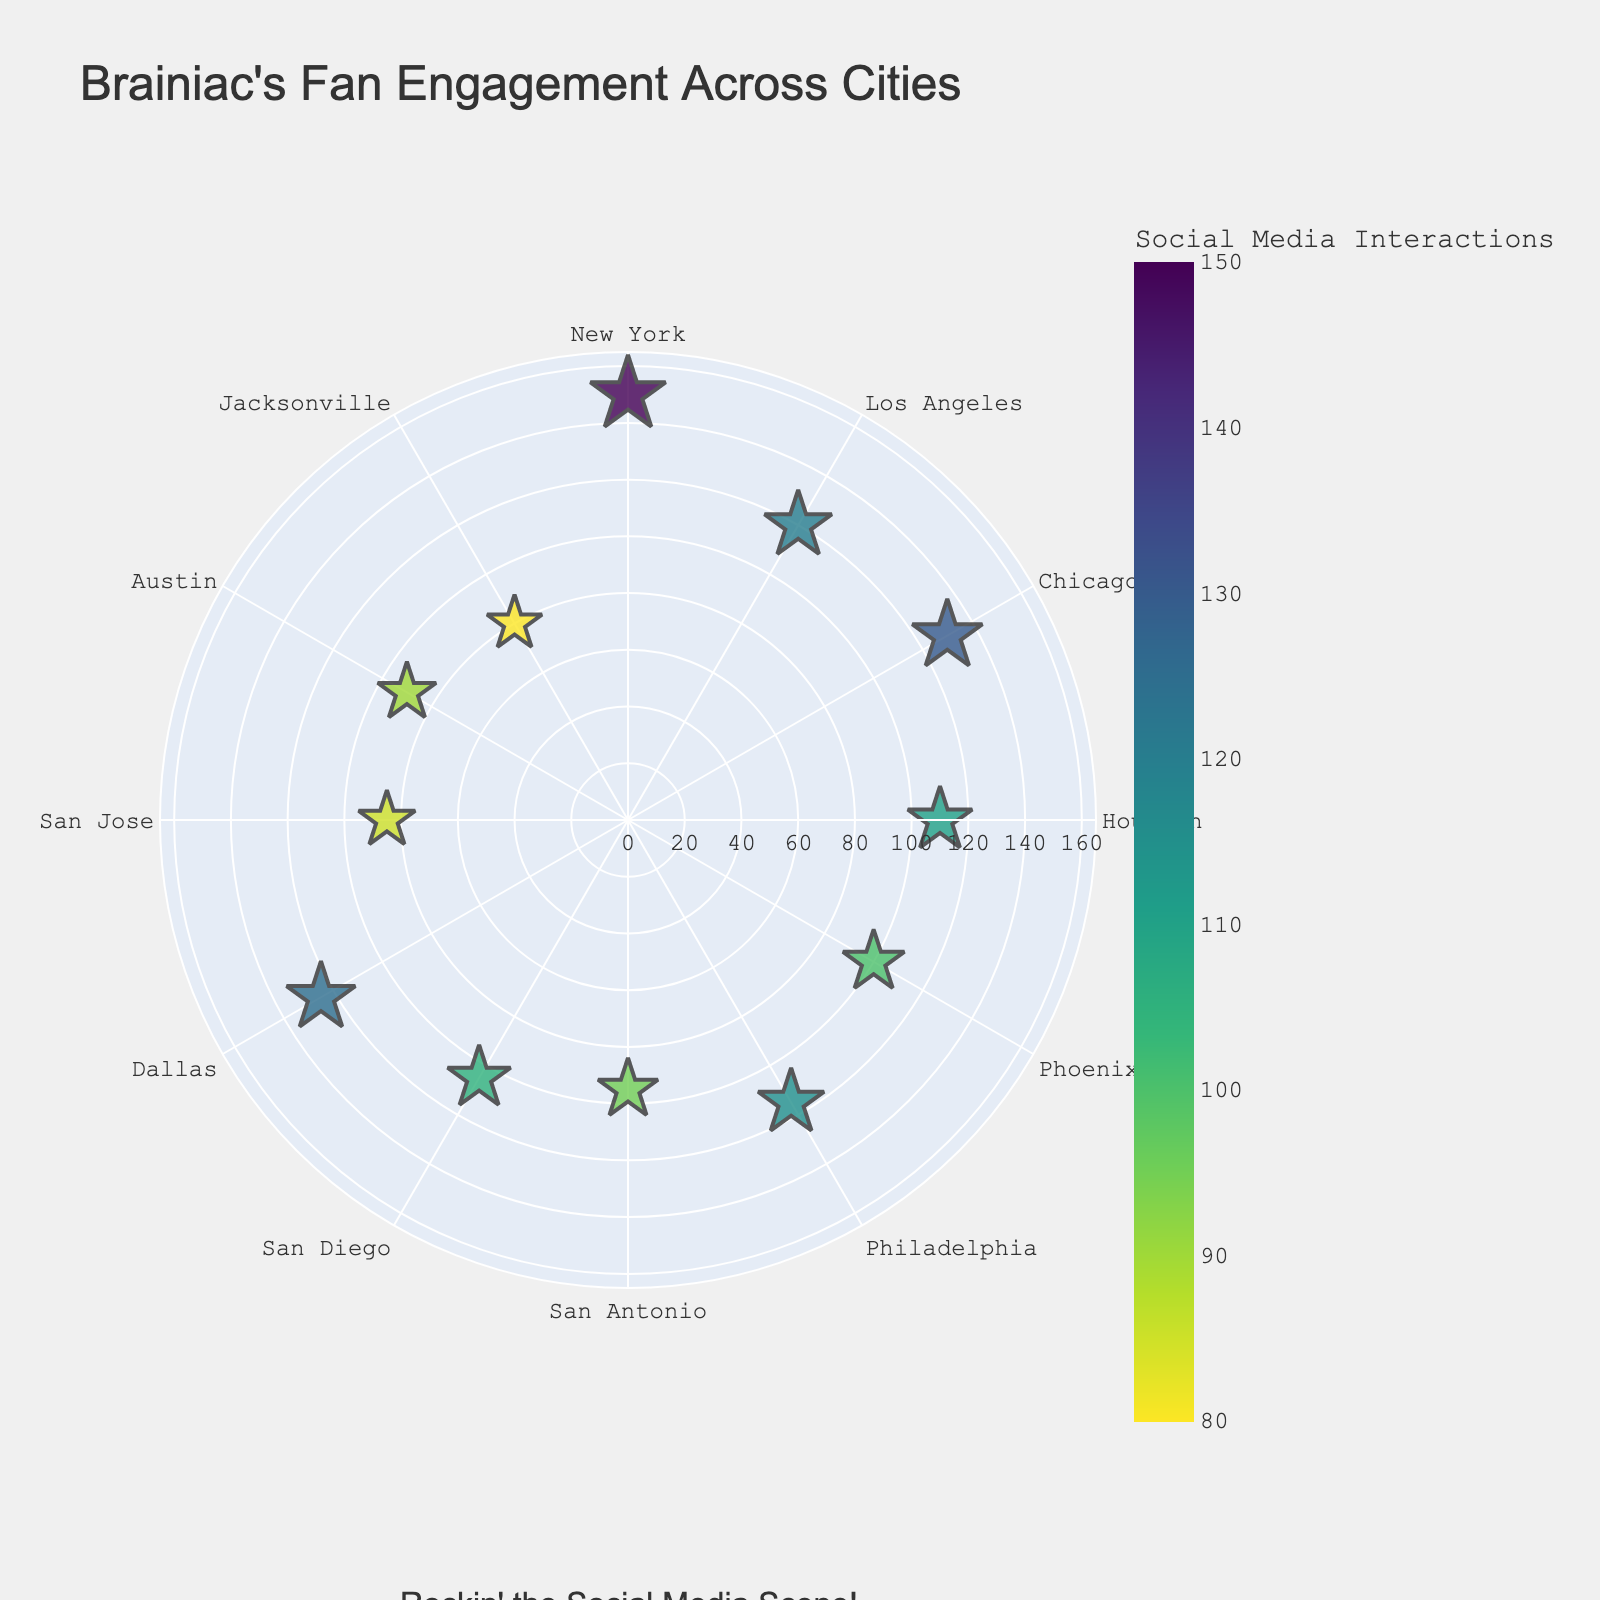What's the title of the plot? The title of the plot is located at the top of the chart. In this case, it reads "Brainiac's Fan Engagement Across Cities."
Answer: Brainiac's Fan Engagement Across Cities How many cities have social media interactions greater than 120? Referencing the chart, identify the points where the radial axis exceeds 120. These cities are New York, Chicago, and Dallas.
Answer: 3 Which city shows the highest number of social media interactions? By looking at the outermost scatter plot point, we see that New York has the highest number of social media interactions.
Answer: New York What is the range of social media interactions shown? The chart displays social media interactions ranging from Jacksonville with 80 interactions to New York with 150 interactions.
Answer: 80 to 150 What's the average number of social media interactions? Summing the interactions (150+120+130+110+100+115+95+105+125+85+90+80) gives 1305. Dividing by the number of cities (12), we get 1305/12 = 108.75.
Answer: 108.75 Which cities have the lowest and highest values separated by more than 60 interactions? The cities with the highest and lowest interactions are New York (150) and Jacksonville (80). The difference between them is 150 - 80 = 70, which is more than 60.
Answer: New York, Jacksonville How does the engagement of San Antonio compare to San Diego? San Antonio has 95 interactions while San Diego has 105 interactions, meaning San Diego has a higher level of engagement than San Antonio.
Answer: San Diego has higher engagement What is the average engagement between Houston and Philadelphia? Adding Houston's interactions (110) and Philadelphia's interactions (115) gives 225. Dividing by 2, we get 225/2 = 112.5.
Answer: 112.5 What cities fall between the 60 and 120-degree angles and what are their interactions? The cities between 60 and 120 degrees are Chicago (130), Houston (110), and Phoenix (100).
Answer: Chicago, Houston, Phoenix Which city at 150 degrees and how many social media interactions does it have? The angular axis label at 150 degrees corresponds to Philadelphia, which has 115 social media interactions.
Answer: Philadelphia, 115 